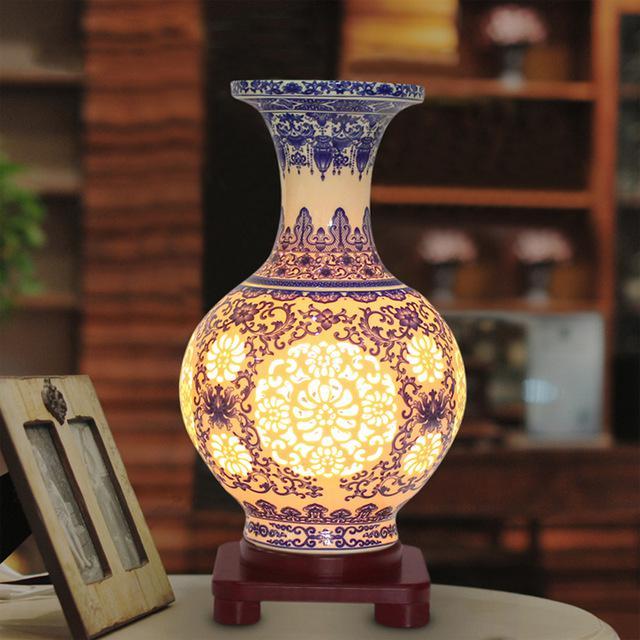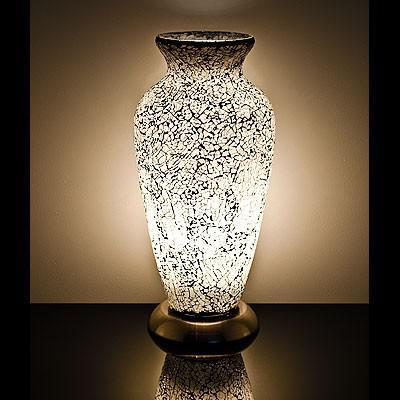The first image is the image on the left, the second image is the image on the right. Examine the images to the left and right. Is the description "Both vases share the same shape." accurate? Answer yes or no. No. The first image is the image on the left, the second image is the image on the right. Considering the images on both sides, is "In both images, rays of light in the background appear to eminate from the vase." valid? Answer yes or no. No. 